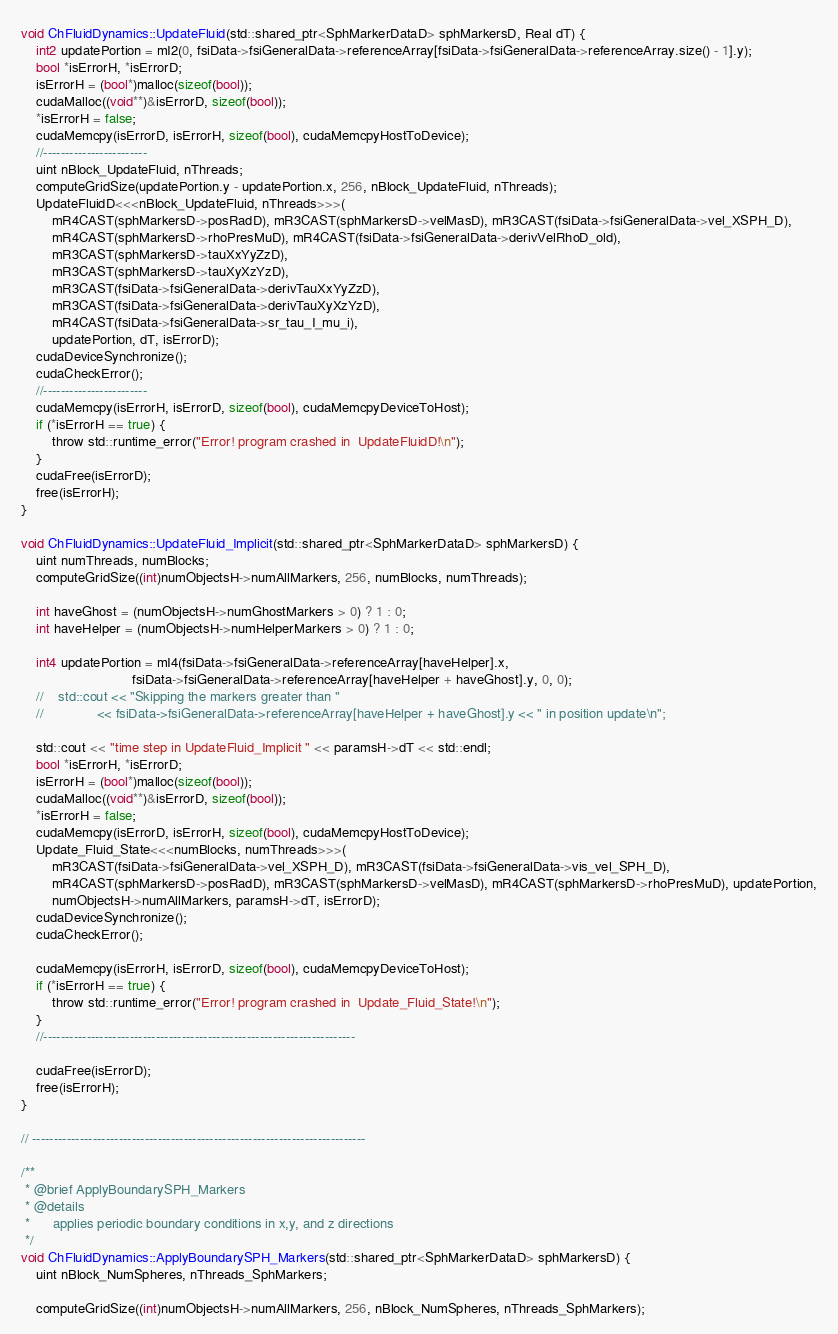<code> <loc_0><loc_0><loc_500><loc_500><_Cuda_>
void ChFluidDynamics::UpdateFluid(std::shared_ptr<SphMarkerDataD> sphMarkersD, Real dT) {
    int2 updatePortion = mI2(0, fsiData->fsiGeneralData->referenceArray[fsiData->fsiGeneralData->referenceArray.size() - 1].y);
    bool *isErrorH, *isErrorD;
    isErrorH = (bool*)malloc(sizeof(bool));
    cudaMalloc((void**)&isErrorD, sizeof(bool));
    *isErrorH = false;
    cudaMemcpy(isErrorD, isErrorH, sizeof(bool), cudaMemcpyHostToDevice);
    //------------------------
    uint nBlock_UpdateFluid, nThreads;
    computeGridSize(updatePortion.y - updatePortion.x, 256, nBlock_UpdateFluid, nThreads);
    UpdateFluidD<<<nBlock_UpdateFluid, nThreads>>>(
        mR4CAST(sphMarkersD->posRadD), mR3CAST(sphMarkersD->velMasD), mR3CAST(fsiData->fsiGeneralData->vel_XSPH_D),
        mR4CAST(sphMarkersD->rhoPresMuD), mR4CAST(fsiData->fsiGeneralData->derivVelRhoD_old),
        mR3CAST(sphMarkersD->tauXxYyZzD),                   
        mR3CAST(sphMarkersD->tauXyXzYzD),                   
        mR3CAST(fsiData->fsiGeneralData->derivTauXxYyZzD),  
        mR3CAST(fsiData->fsiGeneralData->derivTauXyXzYzD), 
        mR4CAST(fsiData->fsiGeneralData->sr_tau_I_mu_i),  
        updatePortion, dT, isErrorD);
    cudaDeviceSynchronize();
    cudaCheckError();
    //------------------------
    cudaMemcpy(isErrorH, isErrorD, sizeof(bool), cudaMemcpyDeviceToHost);
    if (*isErrorH == true) {
        throw std::runtime_error("Error! program crashed in  UpdateFluidD!\n");
    }
    cudaFree(isErrorD);
    free(isErrorH);
}

void ChFluidDynamics::UpdateFluid_Implicit(std::shared_ptr<SphMarkerDataD> sphMarkersD) {
    uint numThreads, numBlocks;
    computeGridSize((int)numObjectsH->numAllMarkers, 256, numBlocks, numThreads);

    int haveGhost = (numObjectsH->numGhostMarkers > 0) ? 1 : 0;
    int haveHelper = (numObjectsH->numHelperMarkers > 0) ? 1 : 0;

    int4 updatePortion = mI4(fsiData->fsiGeneralData->referenceArray[haveHelper].x,
                             fsiData->fsiGeneralData->referenceArray[haveHelper + haveGhost].y, 0, 0);
    //    std::cout << "Skipping the markers greater than "
    //              << fsiData->fsiGeneralData->referenceArray[haveHelper + haveGhost].y << " in position update\n";

    std::cout << "time step in UpdateFluid_Implicit " << paramsH->dT << std::endl;
    bool *isErrorH, *isErrorD;
    isErrorH = (bool*)malloc(sizeof(bool));
    cudaMalloc((void**)&isErrorD, sizeof(bool));
    *isErrorH = false;
    cudaMemcpy(isErrorD, isErrorH, sizeof(bool), cudaMemcpyHostToDevice);
    Update_Fluid_State<<<numBlocks, numThreads>>>(
        mR3CAST(fsiData->fsiGeneralData->vel_XSPH_D), mR3CAST(fsiData->fsiGeneralData->vis_vel_SPH_D),
        mR4CAST(sphMarkersD->posRadD), mR3CAST(sphMarkersD->velMasD), mR4CAST(sphMarkersD->rhoPresMuD), updatePortion,
        numObjectsH->numAllMarkers, paramsH->dT, isErrorD);
    cudaDeviceSynchronize();
    cudaCheckError();

    cudaMemcpy(isErrorH, isErrorD, sizeof(bool), cudaMemcpyDeviceToHost);
    if (*isErrorH == true) {
        throw std::runtime_error("Error! program crashed in  Update_Fluid_State!\n");
    }
    //------------------------------------------------------------------------

    cudaFree(isErrorD);
    free(isErrorH);
}

// -----------------------------------------------------------------------------

/**
 * @brief ApplyBoundarySPH_Markers
 * @details
 * 		applies periodic boundary conditions in x,y, and z directions
 */
void ChFluidDynamics::ApplyBoundarySPH_Markers(std::shared_ptr<SphMarkerDataD> sphMarkersD) {
    uint nBlock_NumSpheres, nThreads_SphMarkers;

    computeGridSize((int)numObjectsH->numAllMarkers, 256, nBlock_NumSpheres, nThreads_SphMarkers);</code> 